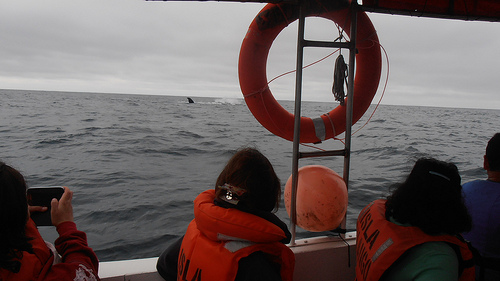<image>
Can you confirm if the ship is in the sea? Yes. The ship is contained within or inside the sea, showing a containment relationship. Is the life jacket in the water? No. The life jacket is not contained within the water. These objects have a different spatial relationship. Is the woman in the sea? No. The woman is not contained within the sea. These objects have a different spatial relationship. 